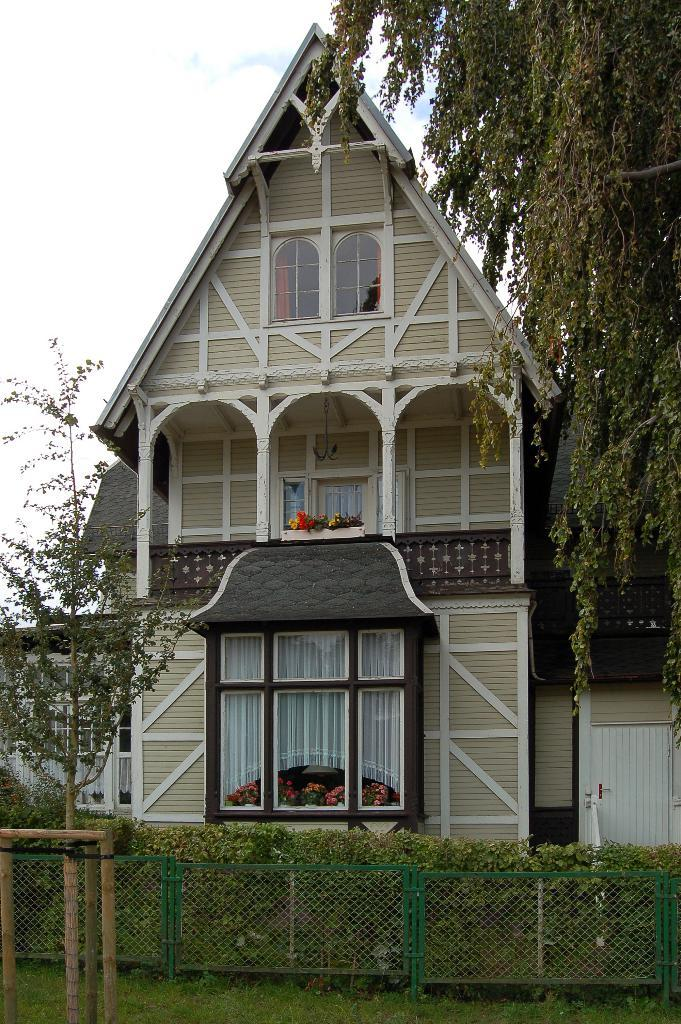What is the main subject in the center of the image? There is a house in the center of the image. What can be seen at the bottom of the image? Fencing, plants, and grass are visible at the bottom of the image. What is visible in the background of the image? Sky and clouds are present in the background of the image. How does the zebra contribute to the digestion process in the image? There is no zebra present in the image, and therefore it cannot contribute to any digestion process. 